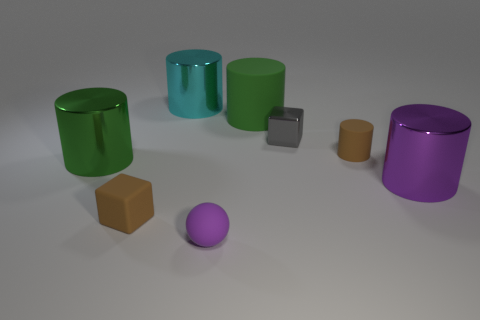Can you describe the size differences between the objects in the image? Certainly! In the image, there is a variety of sizes among the objects. There are two large cylinders, one green and one purple, that dominate the scene in terms of height and volume. In contrast, there are smaller items like the brown and grey cubes, as well as the smallest object, a purple sphere. The cyan cylinder is mid-sized, not as tall as the largest cylinders but noticeably taller than the small cubes and sphere. 